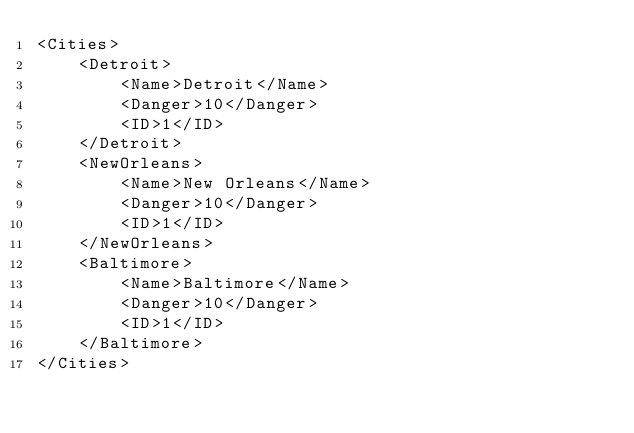Convert code to text. <code><loc_0><loc_0><loc_500><loc_500><_XML_><Cities>
    <Detroit>
        <Name>Detroit</Name>
        <Danger>10</Danger>
        <ID>1</ID>
    </Detroit>
    <NewOrleans>
        <Name>New Orleans</Name>
        <Danger>10</Danger>
        <ID>1</ID>
    </NewOrleans>
    <Baltimore>
        <Name>Baltimore</Name>
        <Danger>10</Danger>
        <ID>1</ID>
    </Baltimore>
</Cities></code> 